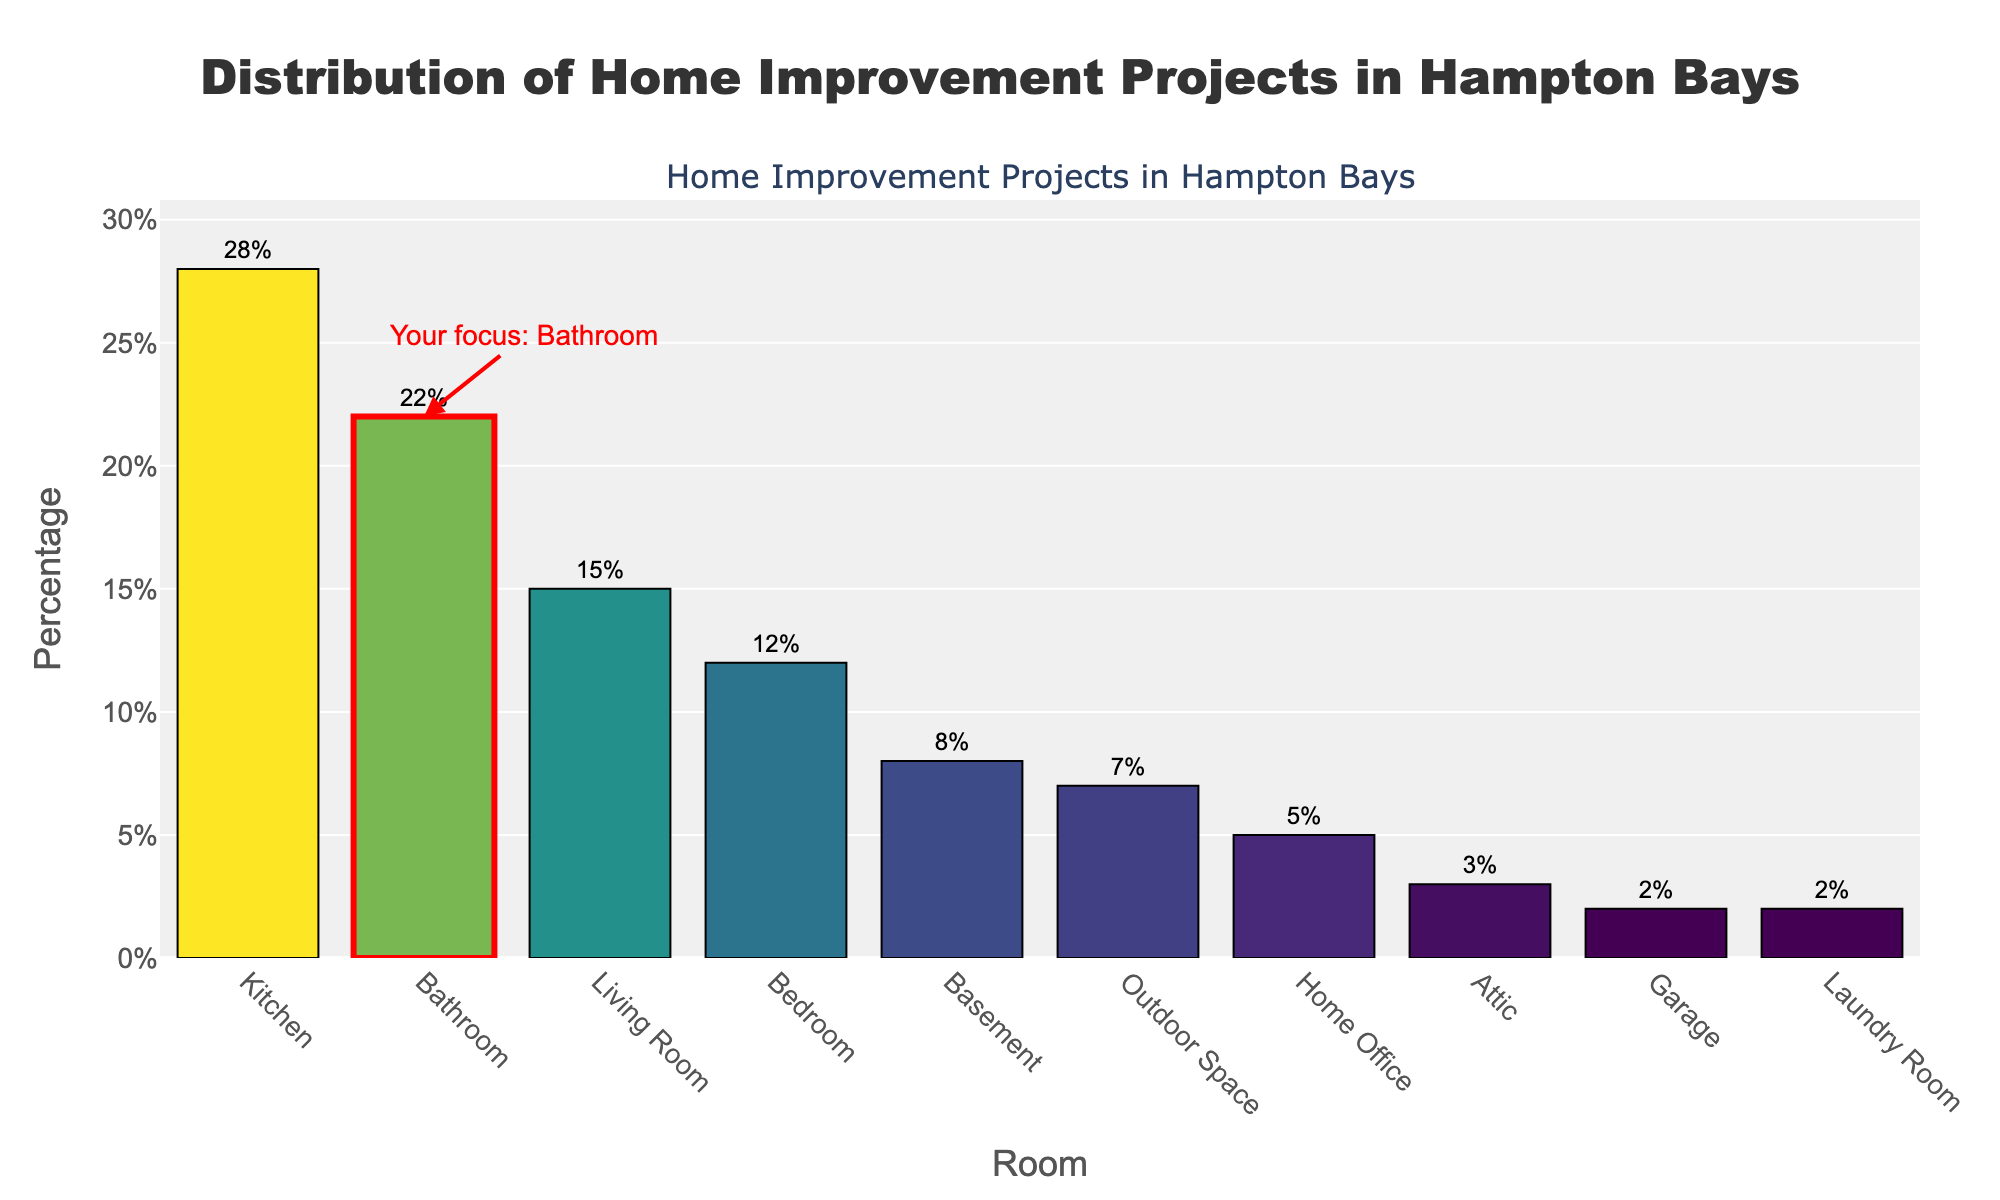what's the room with the least home improvement projects? The room with the least home improvement projects is the one with the smallest bar on the chart, which represents the smallest percentage.
Answer: Garage what's the difference in percentage between Kitchen and Bathroom projects? To find the difference, subtract the percentage for the Bathroom from the percentage for the Kitchen: 28% - 22%.
Answer: 6% what's the total percentage for the projects in the Kitchen and Basement combined? Add the percentages for the Kitchen and Basement: 28% + 8%.
Answer: 36% what's the average percentage of projects for Living Room, Bedroom, and Home Office? Sum the percentages for Living Room, Bedroom, and Home Office, then divide by the number of rooms: (15% + 12% + 5%) / 3.
Answer: 10.67% how many rooms have more than 10% of the home improvement projects? Count the number of bars that represent percentages greater than 10%. These are Kitchen, Bathroom, Living Room, and Bedroom.
Answer: 4 which room has a highlighted bar? The highlighted bar is visually marked with red, and it is labeled with an annotation.
Answer: Bathroom is the highest percentage for Kitchen projects more than double the percentage for Outdoor Space projects? To determine this, compare if 28% is more than twice 7% (2 x 7 = 14%).
Answer: Yes what's the percentage difference between Living Room and Laundry Room projects? Subtract the percentage for Laundry Room from the percentage for Living Room: 15% - 2%.
Answer: 13% how does the percentage for Home Office compare to the percentage for Attic projects? Compare the percentages directly: 5% for Home Office and 3% for Attic. Home Office is greater.
Answer: Home Office is greater what's the sum of percentages for all rooms with less than 5% projects? Sum the percentages for Attic, Garage, and Laundry Room, each of which are under 5%: 3% + 2% + 2%.
Answer: 7% 